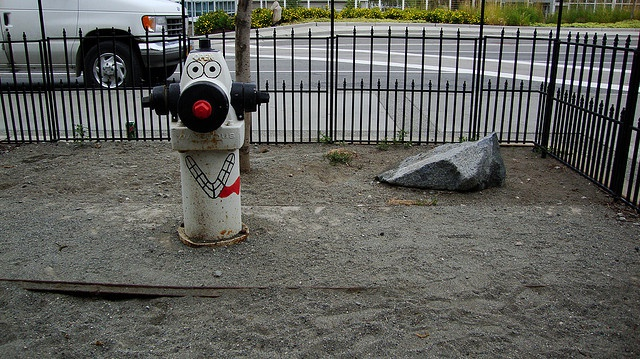Describe the objects in this image and their specific colors. I can see truck in darkgray, black, gray, and lightgray tones and fire hydrant in darkgray, black, gray, and lightgray tones in this image. 